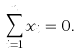Convert formula to latex. <formula><loc_0><loc_0><loc_500><loc_500>\sum _ { i = 1 } ^ { n } x _ { i } = 0 .</formula> 